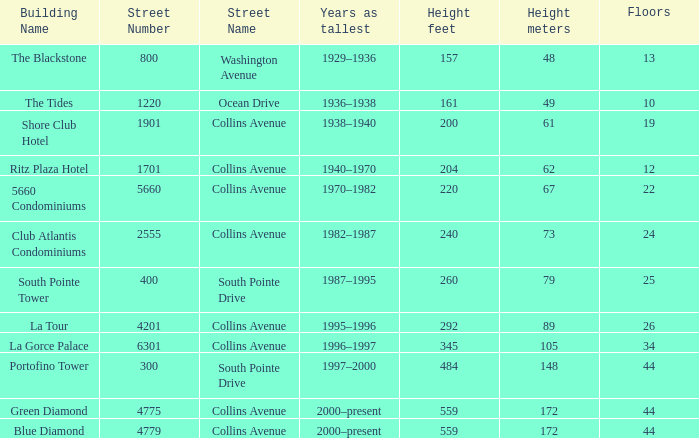How many years was the building with 24 floors the tallest? 1982–1987. 